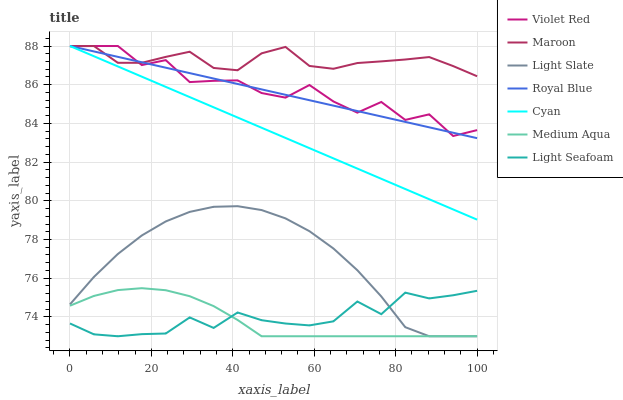Does Light Slate have the minimum area under the curve?
Answer yes or no. No. Does Light Slate have the maximum area under the curve?
Answer yes or no. No. Is Light Slate the smoothest?
Answer yes or no. No. Is Light Slate the roughest?
Answer yes or no. No. Does Maroon have the lowest value?
Answer yes or no. No. Does Light Slate have the highest value?
Answer yes or no. No. Is Light Slate less than Maroon?
Answer yes or no. Yes. Is Maroon greater than Medium Aqua?
Answer yes or no. Yes. Does Light Slate intersect Maroon?
Answer yes or no. No. 